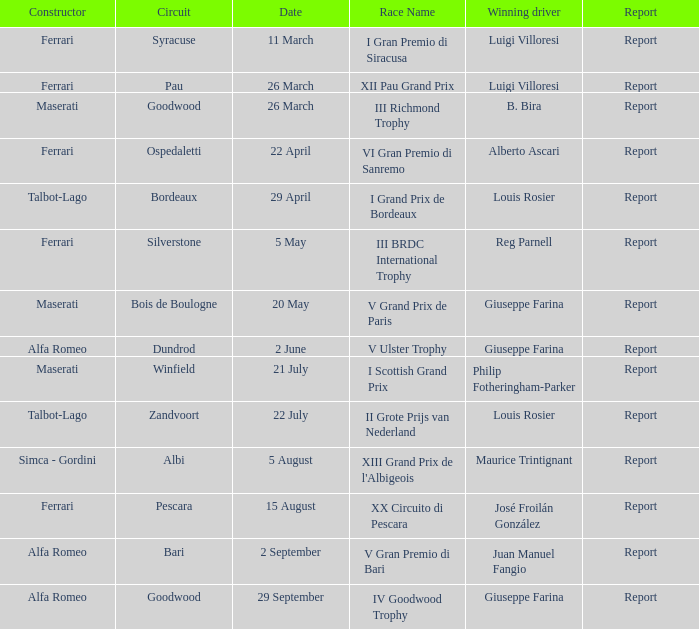Name the date for pescara 15 August. 